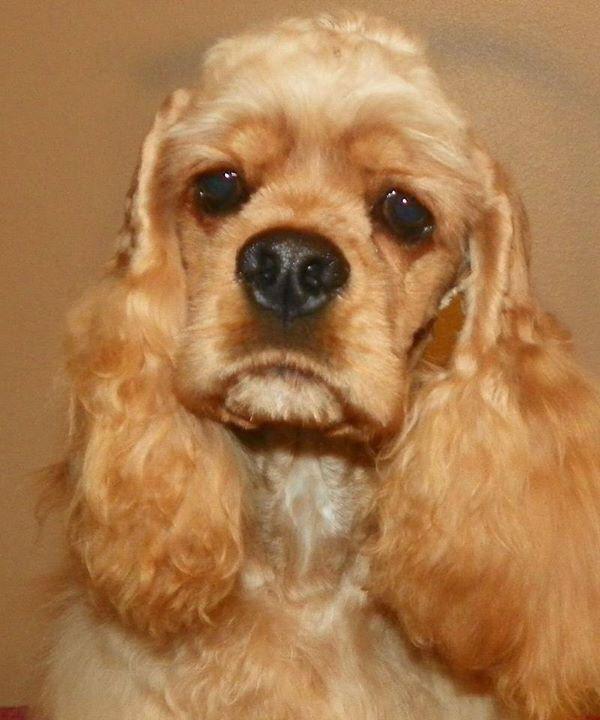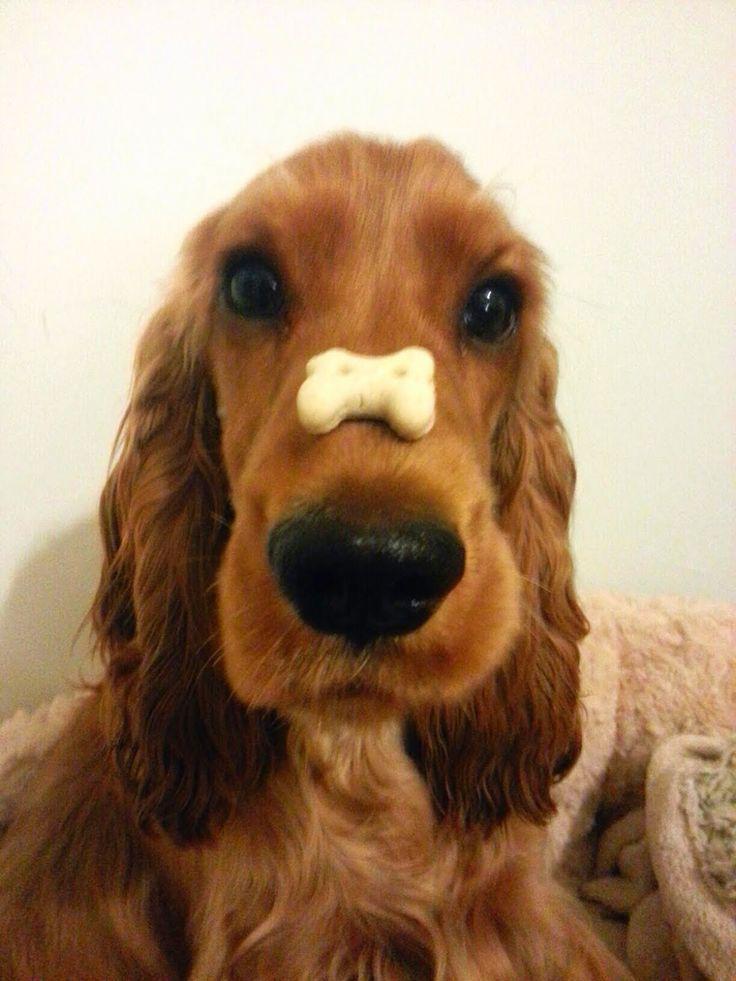The first image is the image on the left, the second image is the image on the right. Examine the images to the left and right. Is the description "the dog on the right image is facing right" accurate? Answer yes or no. No. 